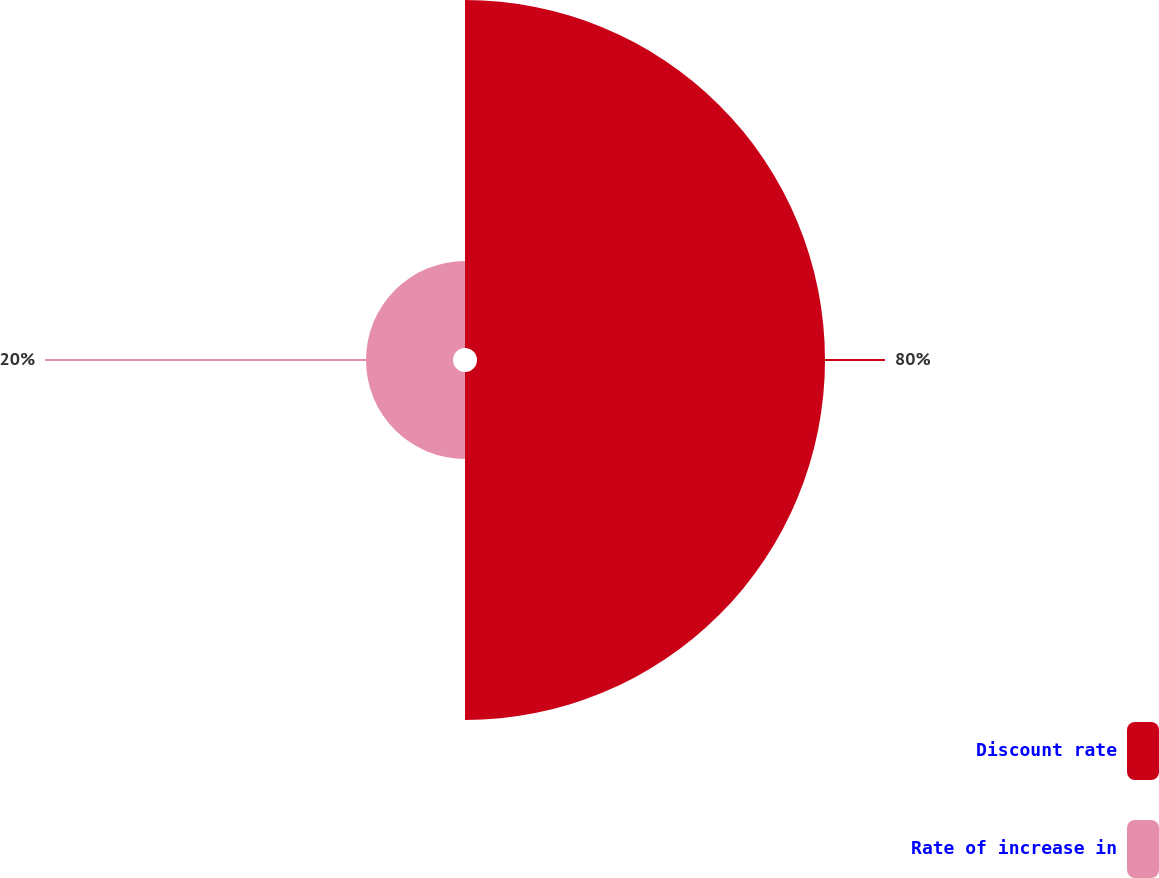Convert chart to OTSL. <chart><loc_0><loc_0><loc_500><loc_500><pie_chart><fcel>Discount rate<fcel>Rate of increase in<nl><fcel>80.0%<fcel>20.0%<nl></chart> 